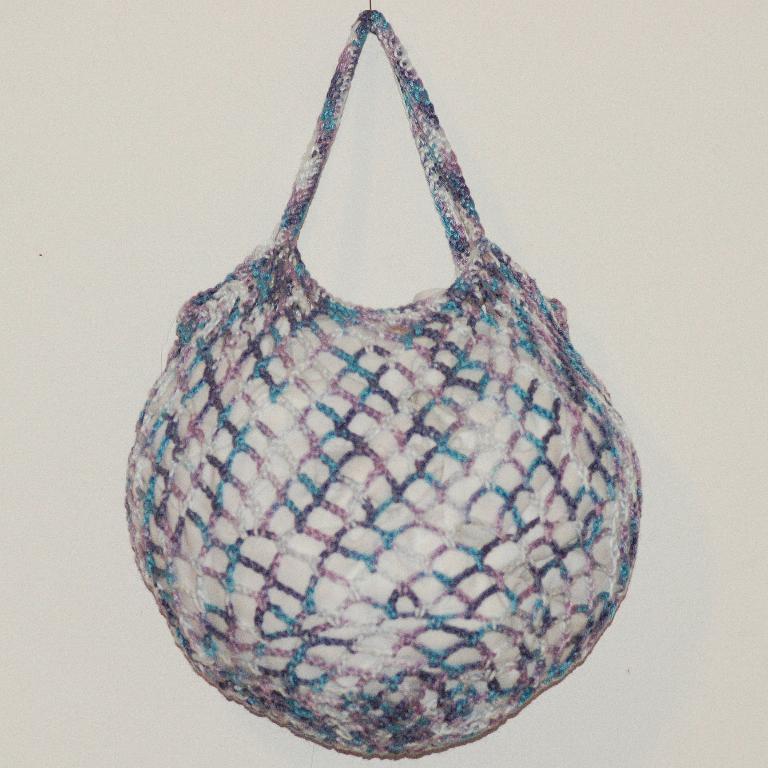Can you describe this image briefly? In this picture we can see a bag which is hanging to the wall. 